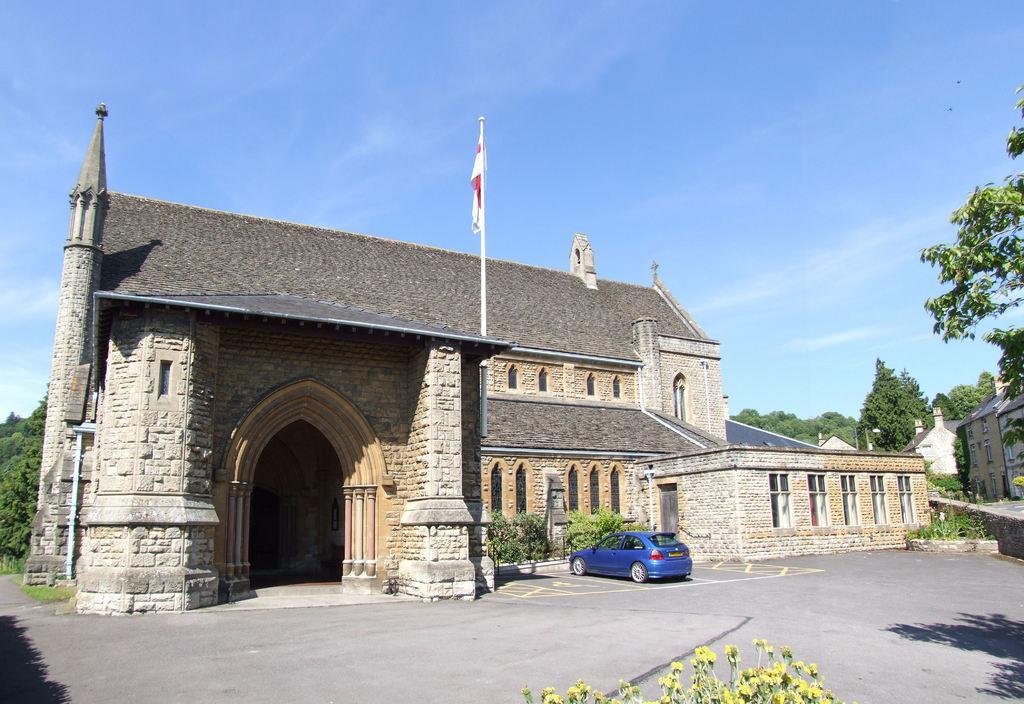How would you summarize this image in a sentence or two? In this picture I can see a vehicle, there are plants, houses, there is a flag with a pole, there are trees, and in the background there is sky. 